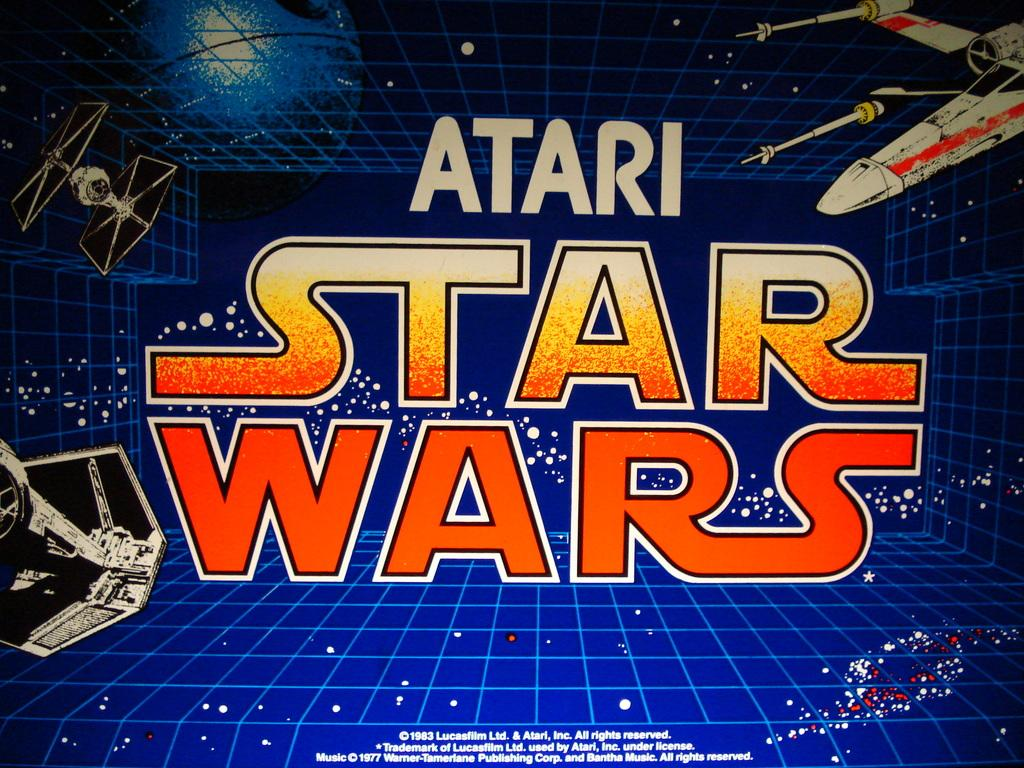What type of visual is the image? The image is a poster. What can be seen on the poster besides text? There are objects on the poster. What is used to convey information or messages on the poster? There is text on the poster. What type of tank is visible on the poster? There is no tank present on the poster; it only contains objects and text. What idea is being conveyed through the branch on the poster? There is no branch present on the poster, so it is not possible to determine what idea might be conveyed through it. 